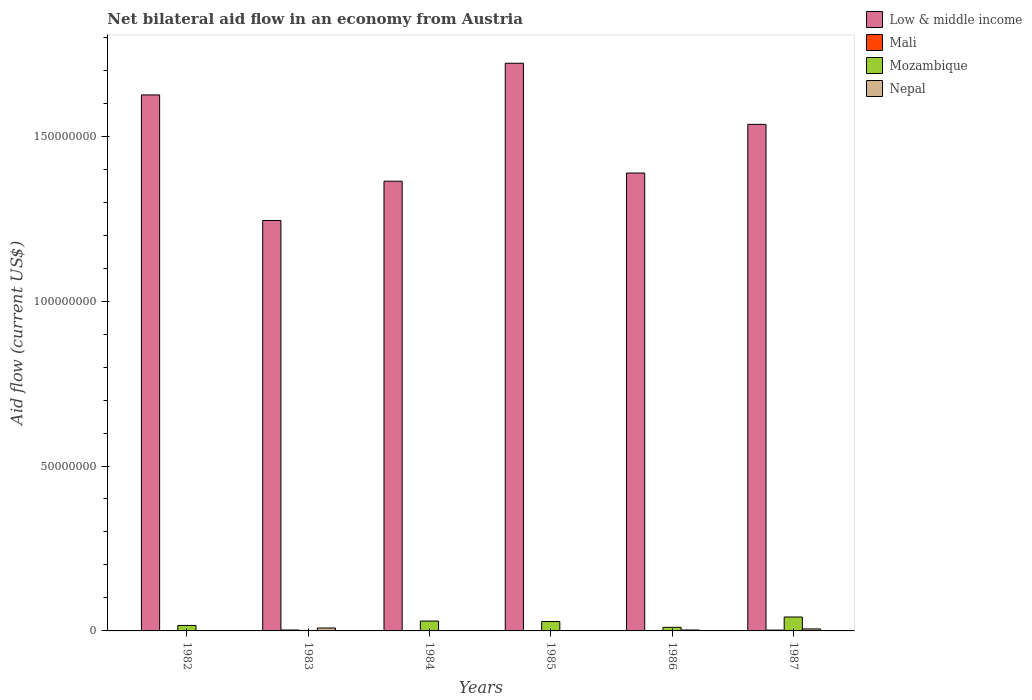How many different coloured bars are there?
Your answer should be compact. 4. How many groups of bars are there?
Ensure brevity in your answer.  6. Are the number of bars per tick equal to the number of legend labels?
Provide a short and direct response. Yes. Are the number of bars on each tick of the X-axis equal?
Keep it short and to the point. Yes. What is the label of the 5th group of bars from the left?
Offer a very short reply. 1986. What is the net bilateral aid flow in Mozambique in 1983?
Your response must be concise. 1.50e+05. Across all years, what is the maximum net bilateral aid flow in Low & middle income?
Provide a short and direct response. 1.72e+08. What is the total net bilateral aid flow in Mozambique in the graph?
Provide a short and direct response. 1.30e+07. What is the difference between the net bilateral aid flow in Nepal in 1983 and that in 1985?
Provide a short and direct response. 8.10e+05. What is the difference between the net bilateral aid flow in Low & middle income in 1982 and the net bilateral aid flow in Mozambique in 1983?
Give a very brief answer. 1.62e+08. What is the average net bilateral aid flow in Mozambique per year?
Give a very brief answer. 2.16e+06. In the year 1984, what is the difference between the net bilateral aid flow in Mali and net bilateral aid flow in Low & middle income?
Keep it short and to the point. -1.36e+08. In how many years, is the net bilateral aid flow in Nepal greater than 40000000 US$?
Your response must be concise. 0. What is the ratio of the net bilateral aid flow in Mozambique in 1983 to that in 1987?
Ensure brevity in your answer.  0.04. Is the net bilateral aid flow in Low & middle income in 1982 less than that in 1986?
Make the answer very short. No. What is the difference between the highest and the second highest net bilateral aid flow in Mali?
Your answer should be very brief. 3.00e+04. What is the difference between the highest and the lowest net bilateral aid flow in Low & middle income?
Ensure brevity in your answer.  4.77e+07. Is it the case that in every year, the sum of the net bilateral aid flow in Low & middle income and net bilateral aid flow in Mali is greater than the sum of net bilateral aid flow in Mozambique and net bilateral aid flow in Nepal?
Offer a terse response. No. What does the 4th bar from the left in 1983 represents?
Offer a terse response. Nepal. What does the 3rd bar from the right in 1985 represents?
Your answer should be compact. Mali. Is it the case that in every year, the sum of the net bilateral aid flow in Mozambique and net bilateral aid flow in Low & middle income is greater than the net bilateral aid flow in Nepal?
Offer a very short reply. Yes. How many bars are there?
Provide a short and direct response. 24. Are all the bars in the graph horizontal?
Keep it short and to the point. No. How many years are there in the graph?
Offer a terse response. 6. What is the difference between two consecutive major ticks on the Y-axis?
Provide a succinct answer. 5.00e+07. Are the values on the major ticks of Y-axis written in scientific E-notation?
Give a very brief answer. No. Does the graph contain grids?
Your answer should be very brief. No. What is the title of the graph?
Your response must be concise. Net bilateral aid flow in an economy from Austria. What is the label or title of the X-axis?
Your response must be concise. Years. What is the label or title of the Y-axis?
Give a very brief answer. Aid flow (current US$). What is the Aid flow (current US$) in Low & middle income in 1982?
Your answer should be very brief. 1.63e+08. What is the Aid flow (current US$) in Mali in 1982?
Give a very brief answer. 3.00e+04. What is the Aid flow (current US$) of Mozambique in 1982?
Make the answer very short. 1.66e+06. What is the Aid flow (current US$) in Low & middle income in 1983?
Provide a succinct answer. 1.24e+08. What is the Aid flow (current US$) of Mali in 1983?
Provide a succinct answer. 2.80e+05. What is the Aid flow (current US$) of Nepal in 1983?
Give a very brief answer. 8.90e+05. What is the Aid flow (current US$) in Low & middle income in 1984?
Your answer should be compact. 1.36e+08. What is the Aid flow (current US$) in Mali in 1984?
Ensure brevity in your answer.  1.30e+05. What is the Aid flow (current US$) of Mozambique in 1984?
Keep it short and to the point. 2.99e+06. What is the Aid flow (current US$) of Nepal in 1984?
Make the answer very short. 4.00e+04. What is the Aid flow (current US$) in Low & middle income in 1985?
Your response must be concise. 1.72e+08. What is the Aid flow (current US$) of Mozambique in 1985?
Your answer should be compact. 2.85e+06. What is the Aid flow (current US$) of Nepal in 1985?
Your answer should be very brief. 8.00e+04. What is the Aid flow (current US$) of Low & middle income in 1986?
Keep it short and to the point. 1.39e+08. What is the Aid flow (current US$) of Mozambique in 1986?
Make the answer very short. 1.09e+06. What is the Aid flow (current US$) of Nepal in 1986?
Provide a succinct answer. 2.80e+05. What is the Aid flow (current US$) in Low & middle income in 1987?
Your answer should be compact. 1.54e+08. What is the Aid flow (current US$) of Mozambique in 1987?
Give a very brief answer. 4.22e+06. What is the Aid flow (current US$) of Nepal in 1987?
Ensure brevity in your answer.  6.10e+05. Across all years, what is the maximum Aid flow (current US$) in Low & middle income?
Provide a succinct answer. 1.72e+08. Across all years, what is the maximum Aid flow (current US$) of Mali?
Provide a succinct answer. 2.80e+05. Across all years, what is the maximum Aid flow (current US$) in Mozambique?
Ensure brevity in your answer.  4.22e+06. Across all years, what is the maximum Aid flow (current US$) in Nepal?
Keep it short and to the point. 8.90e+05. Across all years, what is the minimum Aid flow (current US$) of Low & middle income?
Offer a terse response. 1.24e+08. Across all years, what is the minimum Aid flow (current US$) of Mali?
Offer a terse response. 2.00e+04. What is the total Aid flow (current US$) of Low & middle income in the graph?
Your answer should be very brief. 8.88e+08. What is the total Aid flow (current US$) in Mali in the graph?
Make the answer very short. 7.40e+05. What is the total Aid flow (current US$) of Mozambique in the graph?
Keep it short and to the point. 1.30e+07. What is the total Aid flow (current US$) of Nepal in the graph?
Your response must be concise. 1.95e+06. What is the difference between the Aid flow (current US$) of Low & middle income in 1982 and that in 1983?
Provide a succinct answer. 3.81e+07. What is the difference between the Aid flow (current US$) in Mozambique in 1982 and that in 1983?
Provide a succinct answer. 1.51e+06. What is the difference between the Aid flow (current US$) in Nepal in 1982 and that in 1983?
Provide a short and direct response. -8.40e+05. What is the difference between the Aid flow (current US$) of Low & middle income in 1982 and that in 1984?
Ensure brevity in your answer.  2.62e+07. What is the difference between the Aid flow (current US$) of Mali in 1982 and that in 1984?
Your answer should be compact. -1.00e+05. What is the difference between the Aid flow (current US$) in Mozambique in 1982 and that in 1984?
Provide a short and direct response. -1.33e+06. What is the difference between the Aid flow (current US$) in Nepal in 1982 and that in 1984?
Your response must be concise. 10000. What is the difference between the Aid flow (current US$) of Low & middle income in 1982 and that in 1985?
Provide a succinct answer. -9.60e+06. What is the difference between the Aid flow (current US$) in Mozambique in 1982 and that in 1985?
Provide a succinct answer. -1.19e+06. What is the difference between the Aid flow (current US$) in Nepal in 1982 and that in 1985?
Provide a short and direct response. -3.00e+04. What is the difference between the Aid flow (current US$) of Low & middle income in 1982 and that in 1986?
Your answer should be very brief. 2.37e+07. What is the difference between the Aid flow (current US$) in Mozambique in 1982 and that in 1986?
Ensure brevity in your answer.  5.70e+05. What is the difference between the Aid flow (current US$) in Nepal in 1982 and that in 1986?
Keep it short and to the point. -2.30e+05. What is the difference between the Aid flow (current US$) of Low & middle income in 1982 and that in 1987?
Offer a terse response. 8.93e+06. What is the difference between the Aid flow (current US$) in Mozambique in 1982 and that in 1987?
Ensure brevity in your answer.  -2.56e+06. What is the difference between the Aid flow (current US$) of Nepal in 1982 and that in 1987?
Provide a succinct answer. -5.60e+05. What is the difference between the Aid flow (current US$) of Low & middle income in 1983 and that in 1984?
Provide a short and direct response. -1.19e+07. What is the difference between the Aid flow (current US$) of Mali in 1983 and that in 1984?
Offer a very short reply. 1.50e+05. What is the difference between the Aid flow (current US$) of Mozambique in 1983 and that in 1984?
Provide a succinct answer. -2.84e+06. What is the difference between the Aid flow (current US$) in Nepal in 1983 and that in 1984?
Provide a short and direct response. 8.50e+05. What is the difference between the Aid flow (current US$) of Low & middle income in 1983 and that in 1985?
Keep it short and to the point. -4.77e+07. What is the difference between the Aid flow (current US$) of Mali in 1983 and that in 1985?
Provide a succinct answer. 2.60e+05. What is the difference between the Aid flow (current US$) in Mozambique in 1983 and that in 1985?
Keep it short and to the point. -2.70e+06. What is the difference between the Aid flow (current US$) of Nepal in 1983 and that in 1985?
Your answer should be compact. 8.10e+05. What is the difference between the Aid flow (current US$) of Low & middle income in 1983 and that in 1986?
Your response must be concise. -1.44e+07. What is the difference between the Aid flow (current US$) of Mozambique in 1983 and that in 1986?
Provide a succinct answer. -9.40e+05. What is the difference between the Aid flow (current US$) in Nepal in 1983 and that in 1986?
Ensure brevity in your answer.  6.10e+05. What is the difference between the Aid flow (current US$) in Low & middle income in 1983 and that in 1987?
Your answer should be compact. -2.91e+07. What is the difference between the Aid flow (current US$) of Mozambique in 1983 and that in 1987?
Your response must be concise. -4.07e+06. What is the difference between the Aid flow (current US$) of Low & middle income in 1984 and that in 1985?
Offer a terse response. -3.58e+07. What is the difference between the Aid flow (current US$) of Mali in 1984 and that in 1985?
Ensure brevity in your answer.  1.10e+05. What is the difference between the Aid flow (current US$) of Low & middle income in 1984 and that in 1986?
Give a very brief answer. -2.48e+06. What is the difference between the Aid flow (current US$) in Mozambique in 1984 and that in 1986?
Keep it short and to the point. 1.90e+06. What is the difference between the Aid flow (current US$) in Nepal in 1984 and that in 1986?
Provide a succinct answer. -2.40e+05. What is the difference between the Aid flow (current US$) in Low & middle income in 1984 and that in 1987?
Ensure brevity in your answer.  -1.72e+07. What is the difference between the Aid flow (current US$) in Mali in 1984 and that in 1987?
Make the answer very short. -1.20e+05. What is the difference between the Aid flow (current US$) in Mozambique in 1984 and that in 1987?
Give a very brief answer. -1.23e+06. What is the difference between the Aid flow (current US$) of Nepal in 1984 and that in 1987?
Keep it short and to the point. -5.70e+05. What is the difference between the Aid flow (current US$) in Low & middle income in 1985 and that in 1986?
Give a very brief answer. 3.33e+07. What is the difference between the Aid flow (current US$) of Mozambique in 1985 and that in 1986?
Your response must be concise. 1.76e+06. What is the difference between the Aid flow (current US$) of Nepal in 1985 and that in 1986?
Give a very brief answer. -2.00e+05. What is the difference between the Aid flow (current US$) in Low & middle income in 1985 and that in 1987?
Keep it short and to the point. 1.85e+07. What is the difference between the Aid flow (current US$) in Mali in 1985 and that in 1987?
Provide a short and direct response. -2.30e+05. What is the difference between the Aid flow (current US$) in Mozambique in 1985 and that in 1987?
Your answer should be compact. -1.37e+06. What is the difference between the Aid flow (current US$) of Nepal in 1985 and that in 1987?
Provide a short and direct response. -5.30e+05. What is the difference between the Aid flow (current US$) in Low & middle income in 1986 and that in 1987?
Your answer should be compact. -1.48e+07. What is the difference between the Aid flow (current US$) in Mozambique in 1986 and that in 1987?
Give a very brief answer. -3.13e+06. What is the difference between the Aid flow (current US$) of Nepal in 1986 and that in 1987?
Your response must be concise. -3.30e+05. What is the difference between the Aid flow (current US$) in Low & middle income in 1982 and the Aid flow (current US$) in Mali in 1983?
Give a very brief answer. 1.62e+08. What is the difference between the Aid flow (current US$) of Low & middle income in 1982 and the Aid flow (current US$) of Mozambique in 1983?
Ensure brevity in your answer.  1.62e+08. What is the difference between the Aid flow (current US$) in Low & middle income in 1982 and the Aid flow (current US$) in Nepal in 1983?
Your answer should be very brief. 1.62e+08. What is the difference between the Aid flow (current US$) of Mali in 1982 and the Aid flow (current US$) of Nepal in 1983?
Offer a very short reply. -8.60e+05. What is the difference between the Aid flow (current US$) in Mozambique in 1982 and the Aid flow (current US$) in Nepal in 1983?
Your response must be concise. 7.70e+05. What is the difference between the Aid flow (current US$) in Low & middle income in 1982 and the Aid flow (current US$) in Mali in 1984?
Make the answer very short. 1.62e+08. What is the difference between the Aid flow (current US$) in Low & middle income in 1982 and the Aid flow (current US$) in Mozambique in 1984?
Provide a short and direct response. 1.60e+08. What is the difference between the Aid flow (current US$) in Low & middle income in 1982 and the Aid flow (current US$) in Nepal in 1984?
Ensure brevity in your answer.  1.62e+08. What is the difference between the Aid flow (current US$) of Mali in 1982 and the Aid flow (current US$) of Mozambique in 1984?
Offer a terse response. -2.96e+06. What is the difference between the Aid flow (current US$) of Mozambique in 1982 and the Aid flow (current US$) of Nepal in 1984?
Make the answer very short. 1.62e+06. What is the difference between the Aid flow (current US$) of Low & middle income in 1982 and the Aid flow (current US$) of Mali in 1985?
Provide a succinct answer. 1.62e+08. What is the difference between the Aid flow (current US$) in Low & middle income in 1982 and the Aid flow (current US$) in Mozambique in 1985?
Your response must be concise. 1.60e+08. What is the difference between the Aid flow (current US$) in Low & middle income in 1982 and the Aid flow (current US$) in Nepal in 1985?
Make the answer very short. 1.62e+08. What is the difference between the Aid flow (current US$) in Mali in 1982 and the Aid flow (current US$) in Mozambique in 1985?
Give a very brief answer. -2.82e+06. What is the difference between the Aid flow (current US$) in Mali in 1982 and the Aid flow (current US$) in Nepal in 1985?
Your answer should be very brief. -5.00e+04. What is the difference between the Aid flow (current US$) in Mozambique in 1982 and the Aid flow (current US$) in Nepal in 1985?
Keep it short and to the point. 1.58e+06. What is the difference between the Aid flow (current US$) in Low & middle income in 1982 and the Aid flow (current US$) in Mali in 1986?
Your answer should be compact. 1.62e+08. What is the difference between the Aid flow (current US$) in Low & middle income in 1982 and the Aid flow (current US$) in Mozambique in 1986?
Ensure brevity in your answer.  1.61e+08. What is the difference between the Aid flow (current US$) in Low & middle income in 1982 and the Aid flow (current US$) in Nepal in 1986?
Keep it short and to the point. 1.62e+08. What is the difference between the Aid flow (current US$) of Mali in 1982 and the Aid flow (current US$) of Mozambique in 1986?
Offer a very short reply. -1.06e+06. What is the difference between the Aid flow (current US$) in Mozambique in 1982 and the Aid flow (current US$) in Nepal in 1986?
Provide a short and direct response. 1.38e+06. What is the difference between the Aid flow (current US$) in Low & middle income in 1982 and the Aid flow (current US$) in Mali in 1987?
Keep it short and to the point. 1.62e+08. What is the difference between the Aid flow (current US$) in Low & middle income in 1982 and the Aid flow (current US$) in Mozambique in 1987?
Your answer should be compact. 1.58e+08. What is the difference between the Aid flow (current US$) in Low & middle income in 1982 and the Aid flow (current US$) in Nepal in 1987?
Provide a short and direct response. 1.62e+08. What is the difference between the Aid flow (current US$) of Mali in 1982 and the Aid flow (current US$) of Mozambique in 1987?
Your answer should be very brief. -4.19e+06. What is the difference between the Aid flow (current US$) of Mali in 1982 and the Aid flow (current US$) of Nepal in 1987?
Offer a very short reply. -5.80e+05. What is the difference between the Aid flow (current US$) of Mozambique in 1982 and the Aid flow (current US$) of Nepal in 1987?
Offer a terse response. 1.05e+06. What is the difference between the Aid flow (current US$) of Low & middle income in 1983 and the Aid flow (current US$) of Mali in 1984?
Provide a succinct answer. 1.24e+08. What is the difference between the Aid flow (current US$) of Low & middle income in 1983 and the Aid flow (current US$) of Mozambique in 1984?
Offer a very short reply. 1.21e+08. What is the difference between the Aid flow (current US$) of Low & middle income in 1983 and the Aid flow (current US$) of Nepal in 1984?
Provide a short and direct response. 1.24e+08. What is the difference between the Aid flow (current US$) in Mali in 1983 and the Aid flow (current US$) in Mozambique in 1984?
Ensure brevity in your answer.  -2.71e+06. What is the difference between the Aid flow (current US$) of Mozambique in 1983 and the Aid flow (current US$) of Nepal in 1984?
Offer a terse response. 1.10e+05. What is the difference between the Aid flow (current US$) of Low & middle income in 1983 and the Aid flow (current US$) of Mali in 1985?
Keep it short and to the point. 1.24e+08. What is the difference between the Aid flow (current US$) of Low & middle income in 1983 and the Aid flow (current US$) of Mozambique in 1985?
Ensure brevity in your answer.  1.22e+08. What is the difference between the Aid flow (current US$) of Low & middle income in 1983 and the Aid flow (current US$) of Nepal in 1985?
Give a very brief answer. 1.24e+08. What is the difference between the Aid flow (current US$) of Mali in 1983 and the Aid flow (current US$) of Mozambique in 1985?
Keep it short and to the point. -2.57e+06. What is the difference between the Aid flow (current US$) in Mozambique in 1983 and the Aid flow (current US$) in Nepal in 1985?
Provide a succinct answer. 7.00e+04. What is the difference between the Aid flow (current US$) of Low & middle income in 1983 and the Aid flow (current US$) of Mali in 1986?
Provide a succinct answer. 1.24e+08. What is the difference between the Aid flow (current US$) of Low & middle income in 1983 and the Aid flow (current US$) of Mozambique in 1986?
Your answer should be very brief. 1.23e+08. What is the difference between the Aid flow (current US$) of Low & middle income in 1983 and the Aid flow (current US$) of Nepal in 1986?
Your answer should be compact. 1.24e+08. What is the difference between the Aid flow (current US$) of Mali in 1983 and the Aid flow (current US$) of Mozambique in 1986?
Give a very brief answer. -8.10e+05. What is the difference between the Aid flow (current US$) in Mali in 1983 and the Aid flow (current US$) in Nepal in 1986?
Your response must be concise. 0. What is the difference between the Aid flow (current US$) of Mozambique in 1983 and the Aid flow (current US$) of Nepal in 1986?
Provide a short and direct response. -1.30e+05. What is the difference between the Aid flow (current US$) in Low & middle income in 1983 and the Aid flow (current US$) in Mali in 1987?
Ensure brevity in your answer.  1.24e+08. What is the difference between the Aid flow (current US$) of Low & middle income in 1983 and the Aid flow (current US$) of Mozambique in 1987?
Offer a terse response. 1.20e+08. What is the difference between the Aid flow (current US$) in Low & middle income in 1983 and the Aid flow (current US$) in Nepal in 1987?
Offer a terse response. 1.24e+08. What is the difference between the Aid flow (current US$) of Mali in 1983 and the Aid flow (current US$) of Mozambique in 1987?
Your response must be concise. -3.94e+06. What is the difference between the Aid flow (current US$) of Mali in 1983 and the Aid flow (current US$) of Nepal in 1987?
Provide a succinct answer. -3.30e+05. What is the difference between the Aid flow (current US$) of Mozambique in 1983 and the Aid flow (current US$) of Nepal in 1987?
Provide a short and direct response. -4.60e+05. What is the difference between the Aid flow (current US$) of Low & middle income in 1984 and the Aid flow (current US$) of Mali in 1985?
Make the answer very short. 1.36e+08. What is the difference between the Aid flow (current US$) in Low & middle income in 1984 and the Aid flow (current US$) in Mozambique in 1985?
Give a very brief answer. 1.34e+08. What is the difference between the Aid flow (current US$) in Low & middle income in 1984 and the Aid flow (current US$) in Nepal in 1985?
Keep it short and to the point. 1.36e+08. What is the difference between the Aid flow (current US$) in Mali in 1984 and the Aid flow (current US$) in Mozambique in 1985?
Ensure brevity in your answer.  -2.72e+06. What is the difference between the Aid flow (current US$) of Mali in 1984 and the Aid flow (current US$) of Nepal in 1985?
Ensure brevity in your answer.  5.00e+04. What is the difference between the Aid flow (current US$) of Mozambique in 1984 and the Aid flow (current US$) of Nepal in 1985?
Keep it short and to the point. 2.91e+06. What is the difference between the Aid flow (current US$) of Low & middle income in 1984 and the Aid flow (current US$) of Mali in 1986?
Give a very brief answer. 1.36e+08. What is the difference between the Aid flow (current US$) of Low & middle income in 1984 and the Aid flow (current US$) of Mozambique in 1986?
Your response must be concise. 1.35e+08. What is the difference between the Aid flow (current US$) in Low & middle income in 1984 and the Aid flow (current US$) in Nepal in 1986?
Ensure brevity in your answer.  1.36e+08. What is the difference between the Aid flow (current US$) of Mali in 1984 and the Aid flow (current US$) of Mozambique in 1986?
Your response must be concise. -9.60e+05. What is the difference between the Aid flow (current US$) of Mali in 1984 and the Aid flow (current US$) of Nepal in 1986?
Your response must be concise. -1.50e+05. What is the difference between the Aid flow (current US$) in Mozambique in 1984 and the Aid flow (current US$) in Nepal in 1986?
Offer a terse response. 2.71e+06. What is the difference between the Aid flow (current US$) in Low & middle income in 1984 and the Aid flow (current US$) in Mali in 1987?
Provide a short and direct response. 1.36e+08. What is the difference between the Aid flow (current US$) of Low & middle income in 1984 and the Aid flow (current US$) of Mozambique in 1987?
Keep it short and to the point. 1.32e+08. What is the difference between the Aid flow (current US$) of Low & middle income in 1984 and the Aid flow (current US$) of Nepal in 1987?
Give a very brief answer. 1.36e+08. What is the difference between the Aid flow (current US$) of Mali in 1984 and the Aid flow (current US$) of Mozambique in 1987?
Ensure brevity in your answer.  -4.09e+06. What is the difference between the Aid flow (current US$) in Mali in 1984 and the Aid flow (current US$) in Nepal in 1987?
Give a very brief answer. -4.80e+05. What is the difference between the Aid flow (current US$) of Mozambique in 1984 and the Aid flow (current US$) of Nepal in 1987?
Make the answer very short. 2.38e+06. What is the difference between the Aid flow (current US$) in Low & middle income in 1985 and the Aid flow (current US$) in Mali in 1986?
Make the answer very short. 1.72e+08. What is the difference between the Aid flow (current US$) in Low & middle income in 1985 and the Aid flow (current US$) in Mozambique in 1986?
Ensure brevity in your answer.  1.71e+08. What is the difference between the Aid flow (current US$) in Low & middle income in 1985 and the Aid flow (current US$) in Nepal in 1986?
Keep it short and to the point. 1.72e+08. What is the difference between the Aid flow (current US$) in Mali in 1985 and the Aid flow (current US$) in Mozambique in 1986?
Your answer should be very brief. -1.07e+06. What is the difference between the Aid flow (current US$) of Mozambique in 1985 and the Aid flow (current US$) of Nepal in 1986?
Your answer should be compact. 2.57e+06. What is the difference between the Aid flow (current US$) of Low & middle income in 1985 and the Aid flow (current US$) of Mali in 1987?
Keep it short and to the point. 1.72e+08. What is the difference between the Aid flow (current US$) in Low & middle income in 1985 and the Aid flow (current US$) in Mozambique in 1987?
Provide a short and direct response. 1.68e+08. What is the difference between the Aid flow (current US$) of Low & middle income in 1985 and the Aid flow (current US$) of Nepal in 1987?
Provide a short and direct response. 1.72e+08. What is the difference between the Aid flow (current US$) of Mali in 1985 and the Aid flow (current US$) of Mozambique in 1987?
Provide a succinct answer. -4.20e+06. What is the difference between the Aid flow (current US$) in Mali in 1985 and the Aid flow (current US$) in Nepal in 1987?
Offer a terse response. -5.90e+05. What is the difference between the Aid flow (current US$) of Mozambique in 1985 and the Aid flow (current US$) of Nepal in 1987?
Provide a succinct answer. 2.24e+06. What is the difference between the Aid flow (current US$) of Low & middle income in 1986 and the Aid flow (current US$) of Mali in 1987?
Give a very brief answer. 1.39e+08. What is the difference between the Aid flow (current US$) of Low & middle income in 1986 and the Aid flow (current US$) of Mozambique in 1987?
Your answer should be very brief. 1.35e+08. What is the difference between the Aid flow (current US$) of Low & middle income in 1986 and the Aid flow (current US$) of Nepal in 1987?
Your answer should be very brief. 1.38e+08. What is the difference between the Aid flow (current US$) of Mali in 1986 and the Aid flow (current US$) of Mozambique in 1987?
Make the answer very short. -4.19e+06. What is the difference between the Aid flow (current US$) in Mali in 1986 and the Aid flow (current US$) in Nepal in 1987?
Offer a terse response. -5.80e+05. What is the difference between the Aid flow (current US$) of Mozambique in 1986 and the Aid flow (current US$) of Nepal in 1987?
Your answer should be compact. 4.80e+05. What is the average Aid flow (current US$) of Low & middle income per year?
Make the answer very short. 1.48e+08. What is the average Aid flow (current US$) in Mali per year?
Give a very brief answer. 1.23e+05. What is the average Aid flow (current US$) of Mozambique per year?
Ensure brevity in your answer.  2.16e+06. What is the average Aid flow (current US$) of Nepal per year?
Provide a succinct answer. 3.25e+05. In the year 1982, what is the difference between the Aid flow (current US$) in Low & middle income and Aid flow (current US$) in Mali?
Make the answer very short. 1.62e+08. In the year 1982, what is the difference between the Aid flow (current US$) of Low & middle income and Aid flow (current US$) of Mozambique?
Offer a very short reply. 1.61e+08. In the year 1982, what is the difference between the Aid flow (current US$) of Low & middle income and Aid flow (current US$) of Nepal?
Your response must be concise. 1.62e+08. In the year 1982, what is the difference between the Aid flow (current US$) in Mali and Aid flow (current US$) in Mozambique?
Your answer should be very brief. -1.63e+06. In the year 1982, what is the difference between the Aid flow (current US$) in Mozambique and Aid flow (current US$) in Nepal?
Ensure brevity in your answer.  1.61e+06. In the year 1983, what is the difference between the Aid flow (current US$) of Low & middle income and Aid flow (current US$) of Mali?
Provide a short and direct response. 1.24e+08. In the year 1983, what is the difference between the Aid flow (current US$) of Low & middle income and Aid flow (current US$) of Mozambique?
Make the answer very short. 1.24e+08. In the year 1983, what is the difference between the Aid flow (current US$) in Low & middle income and Aid flow (current US$) in Nepal?
Provide a succinct answer. 1.24e+08. In the year 1983, what is the difference between the Aid flow (current US$) of Mali and Aid flow (current US$) of Nepal?
Offer a very short reply. -6.10e+05. In the year 1983, what is the difference between the Aid flow (current US$) in Mozambique and Aid flow (current US$) in Nepal?
Offer a very short reply. -7.40e+05. In the year 1984, what is the difference between the Aid flow (current US$) of Low & middle income and Aid flow (current US$) of Mali?
Keep it short and to the point. 1.36e+08. In the year 1984, what is the difference between the Aid flow (current US$) of Low & middle income and Aid flow (current US$) of Mozambique?
Make the answer very short. 1.33e+08. In the year 1984, what is the difference between the Aid flow (current US$) of Low & middle income and Aid flow (current US$) of Nepal?
Your response must be concise. 1.36e+08. In the year 1984, what is the difference between the Aid flow (current US$) of Mali and Aid flow (current US$) of Mozambique?
Keep it short and to the point. -2.86e+06. In the year 1984, what is the difference between the Aid flow (current US$) in Mozambique and Aid flow (current US$) in Nepal?
Your answer should be compact. 2.95e+06. In the year 1985, what is the difference between the Aid flow (current US$) in Low & middle income and Aid flow (current US$) in Mali?
Your answer should be very brief. 1.72e+08. In the year 1985, what is the difference between the Aid flow (current US$) in Low & middle income and Aid flow (current US$) in Mozambique?
Offer a very short reply. 1.69e+08. In the year 1985, what is the difference between the Aid flow (current US$) of Low & middle income and Aid flow (current US$) of Nepal?
Provide a succinct answer. 1.72e+08. In the year 1985, what is the difference between the Aid flow (current US$) of Mali and Aid flow (current US$) of Mozambique?
Your answer should be compact. -2.83e+06. In the year 1985, what is the difference between the Aid flow (current US$) in Mozambique and Aid flow (current US$) in Nepal?
Give a very brief answer. 2.77e+06. In the year 1986, what is the difference between the Aid flow (current US$) in Low & middle income and Aid flow (current US$) in Mali?
Provide a succinct answer. 1.39e+08. In the year 1986, what is the difference between the Aid flow (current US$) of Low & middle income and Aid flow (current US$) of Mozambique?
Your response must be concise. 1.38e+08. In the year 1986, what is the difference between the Aid flow (current US$) of Low & middle income and Aid flow (current US$) of Nepal?
Keep it short and to the point. 1.39e+08. In the year 1986, what is the difference between the Aid flow (current US$) in Mali and Aid flow (current US$) in Mozambique?
Provide a short and direct response. -1.06e+06. In the year 1986, what is the difference between the Aid flow (current US$) of Mali and Aid flow (current US$) of Nepal?
Provide a succinct answer. -2.50e+05. In the year 1986, what is the difference between the Aid flow (current US$) in Mozambique and Aid flow (current US$) in Nepal?
Your answer should be compact. 8.10e+05. In the year 1987, what is the difference between the Aid flow (current US$) of Low & middle income and Aid flow (current US$) of Mali?
Provide a succinct answer. 1.53e+08. In the year 1987, what is the difference between the Aid flow (current US$) of Low & middle income and Aid flow (current US$) of Mozambique?
Your response must be concise. 1.49e+08. In the year 1987, what is the difference between the Aid flow (current US$) in Low & middle income and Aid flow (current US$) in Nepal?
Give a very brief answer. 1.53e+08. In the year 1987, what is the difference between the Aid flow (current US$) of Mali and Aid flow (current US$) of Mozambique?
Make the answer very short. -3.97e+06. In the year 1987, what is the difference between the Aid flow (current US$) of Mali and Aid flow (current US$) of Nepal?
Keep it short and to the point. -3.60e+05. In the year 1987, what is the difference between the Aid flow (current US$) in Mozambique and Aid flow (current US$) in Nepal?
Provide a short and direct response. 3.61e+06. What is the ratio of the Aid flow (current US$) of Low & middle income in 1982 to that in 1983?
Offer a very short reply. 1.31. What is the ratio of the Aid flow (current US$) in Mali in 1982 to that in 1983?
Keep it short and to the point. 0.11. What is the ratio of the Aid flow (current US$) in Mozambique in 1982 to that in 1983?
Give a very brief answer. 11.07. What is the ratio of the Aid flow (current US$) of Nepal in 1982 to that in 1983?
Provide a succinct answer. 0.06. What is the ratio of the Aid flow (current US$) in Low & middle income in 1982 to that in 1984?
Provide a short and direct response. 1.19. What is the ratio of the Aid flow (current US$) in Mali in 1982 to that in 1984?
Keep it short and to the point. 0.23. What is the ratio of the Aid flow (current US$) in Mozambique in 1982 to that in 1984?
Provide a succinct answer. 0.56. What is the ratio of the Aid flow (current US$) in Nepal in 1982 to that in 1984?
Give a very brief answer. 1.25. What is the ratio of the Aid flow (current US$) of Low & middle income in 1982 to that in 1985?
Offer a very short reply. 0.94. What is the ratio of the Aid flow (current US$) in Mali in 1982 to that in 1985?
Ensure brevity in your answer.  1.5. What is the ratio of the Aid flow (current US$) of Mozambique in 1982 to that in 1985?
Your response must be concise. 0.58. What is the ratio of the Aid flow (current US$) in Low & middle income in 1982 to that in 1986?
Ensure brevity in your answer.  1.17. What is the ratio of the Aid flow (current US$) of Mali in 1982 to that in 1986?
Your answer should be compact. 1. What is the ratio of the Aid flow (current US$) in Mozambique in 1982 to that in 1986?
Provide a short and direct response. 1.52. What is the ratio of the Aid flow (current US$) of Nepal in 1982 to that in 1986?
Provide a short and direct response. 0.18. What is the ratio of the Aid flow (current US$) of Low & middle income in 1982 to that in 1987?
Offer a terse response. 1.06. What is the ratio of the Aid flow (current US$) of Mali in 1982 to that in 1987?
Offer a terse response. 0.12. What is the ratio of the Aid flow (current US$) of Mozambique in 1982 to that in 1987?
Provide a short and direct response. 0.39. What is the ratio of the Aid flow (current US$) in Nepal in 1982 to that in 1987?
Your answer should be very brief. 0.08. What is the ratio of the Aid flow (current US$) in Low & middle income in 1983 to that in 1984?
Give a very brief answer. 0.91. What is the ratio of the Aid flow (current US$) in Mali in 1983 to that in 1984?
Ensure brevity in your answer.  2.15. What is the ratio of the Aid flow (current US$) in Mozambique in 1983 to that in 1984?
Ensure brevity in your answer.  0.05. What is the ratio of the Aid flow (current US$) of Nepal in 1983 to that in 1984?
Your response must be concise. 22.25. What is the ratio of the Aid flow (current US$) of Low & middle income in 1983 to that in 1985?
Offer a terse response. 0.72. What is the ratio of the Aid flow (current US$) in Mali in 1983 to that in 1985?
Keep it short and to the point. 14. What is the ratio of the Aid flow (current US$) in Mozambique in 1983 to that in 1985?
Your response must be concise. 0.05. What is the ratio of the Aid flow (current US$) of Nepal in 1983 to that in 1985?
Give a very brief answer. 11.12. What is the ratio of the Aid flow (current US$) of Low & middle income in 1983 to that in 1986?
Provide a succinct answer. 0.9. What is the ratio of the Aid flow (current US$) of Mali in 1983 to that in 1986?
Keep it short and to the point. 9.33. What is the ratio of the Aid flow (current US$) in Mozambique in 1983 to that in 1986?
Your answer should be compact. 0.14. What is the ratio of the Aid flow (current US$) of Nepal in 1983 to that in 1986?
Give a very brief answer. 3.18. What is the ratio of the Aid flow (current US$) in Low & middle income in 1983 to that in 1987?
Make the answer very short. 0.81. What is the ratio of the Aid flow (current US$) of Mali in 1983 to that in 1987?
Give a very brief answer. 1.12. What is the ratio of the Aid flow (current US$) in Mozambique in 1983 to that in 1987?
Make the answer very short. 0.04. What is the ratio of the Aid flow (current US$) of Nepal in 1983 to that in 1987?
Your response must be concise. 1.46. What is the ratio of the Aid flow (current US$) in Low & middle income in 1984 to that in 1985?
Your response must be concise. 0.79. What is the ratio of the Aid flow (current US$) in Mali in 1984 to that in 1985?
Offer a terse response. 6.5. What is the ratio of the Aid flow (current US$) of Mozambique in 1984 to that in 1985?
Provide a short and direct response. 1.05. What is the ratio of the Aid flow (current US$) of Nepal in 1984 to that in 1985?
Make the answer very short. 0.5. What is the ratio of the Aid flow (current US$) of Low & middle income in 1984 to that in 1986?
Give a very brief answer. 0.98. What is the ratio of the Aid flow (current US$) of Mali in 1984 to that in 1986?
Your answer should be very brief. 4.33. What is the ratio of the Aid flow (current US$) of Mozambique in 1984 to that in 1986?
Ensure brevity in your answer.  2.74. What is the ratio of the Aid flow (current US$) in Nepal in 1984 to that in 1986?
Your answer should be very brief. 0.14. What is the ratio of the Aid flow (current US$) in Low & middle income in 1984 to that in 1987?
Give a very brief answer. 0.89. What is the ratio of the Aid flow (current US$) in Mali in 1984 to that in 1987?
Keep it short and to the point. 0.52. What is the ratio of the Aid flow (current US$) in Mozambique in 1984 to that in 1987?
Keep it short and to the point. 0.71. What is the ratio of the Aid flow (current US$) in Nepal in 1984 to that in 1987?
Give a very brief answer. 0.07. What is the ratio of the Aid flow (current US$) of Low & middle income in 1985 to that in 1986?
Offer a very short reply. 1.24. What is the ratio of the Aid flow (current US$) in Mali in 1985 to that in 1986?
Provide a succinct answer. 0.67. What is the ratio of the Aid flow (current US$) of Mozambique in 1985 to that in 1986?
Ensure brevity in your answer.  2.61. What is the ratio of the Aid flow (current US$) in Nepal in 1985 to that in 1986?
Offer a very short reply. 0.29. What is the ratio of the Aid flow (current US$) in Low & middle income in 1985 to that in 1987?
Your answer should be very brief. 1.12. What is the ratio of the Aid flow (current US$) in Mali in 1985 to that in 1987?
Your answer should be compact. 0.08. What is the ratio of the Aid flow (current US$) in Mozambique in 1985 to that in 1987?
Make the answer very short. 0.68. What is the ratio of the Aid flow (current US$) of Nepal in 1985 to that in 1987?
Provide a succinct answer. 0.13. What is the ratio of the Aid flow (current US$) in Low & middle income in 1986 to that in 1987?
Ensure brevity in your answer.  0.9. What is the ratio of the Aid flow (current US$) in Mali in 1986 to that in 1987?
Offer a very short reply. 0.12. What is the ratio of the Aid flow (current US$) of Mozambique in 1986 to that in 1987?
Ensure brevity in your answer.  0.26. What is the ratio of the Aid flow (current US$) of Nepal in 1986 to that in 1987?
Ensure brevity in your answer.  0.46. What is the difference between the highest and the second highest Aid flow (current US$) in Low & middle income?
Your response must be concise. 9.60e+06. What is the difference between the highest and the second highest Aid flow (current US$) of Mozambique?
Ensure brevity in your answer.  1.23e+06. What is the difference between the highest and the second highest Aid flow (current US$) of Nepal?
Keep it short and to the point. 2.80e+05. What is the difference between the highest and the lowest Aid flow (current US$) in Low & middle income?
Your answer should be compact. 4.77e+07. What is the difference between the highest and the lowest Aid flow (current US$) of Mozambique?
Provide a short and direct response. 4.07e+06. What is the difference between the highest and the lowest Aid flow (current US$) of Nepal?
Your answer should be very brief. 8.50e+05. 